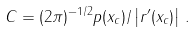<formula> <loc_0><loc_0><loc_500><loc_500>C = ( 2 \pi ) ^ { - 1 / 2 } p ( x _ { c } ) / \left | r ^ { \prime } ( x _ { c } ) \right | \, .</formula> 